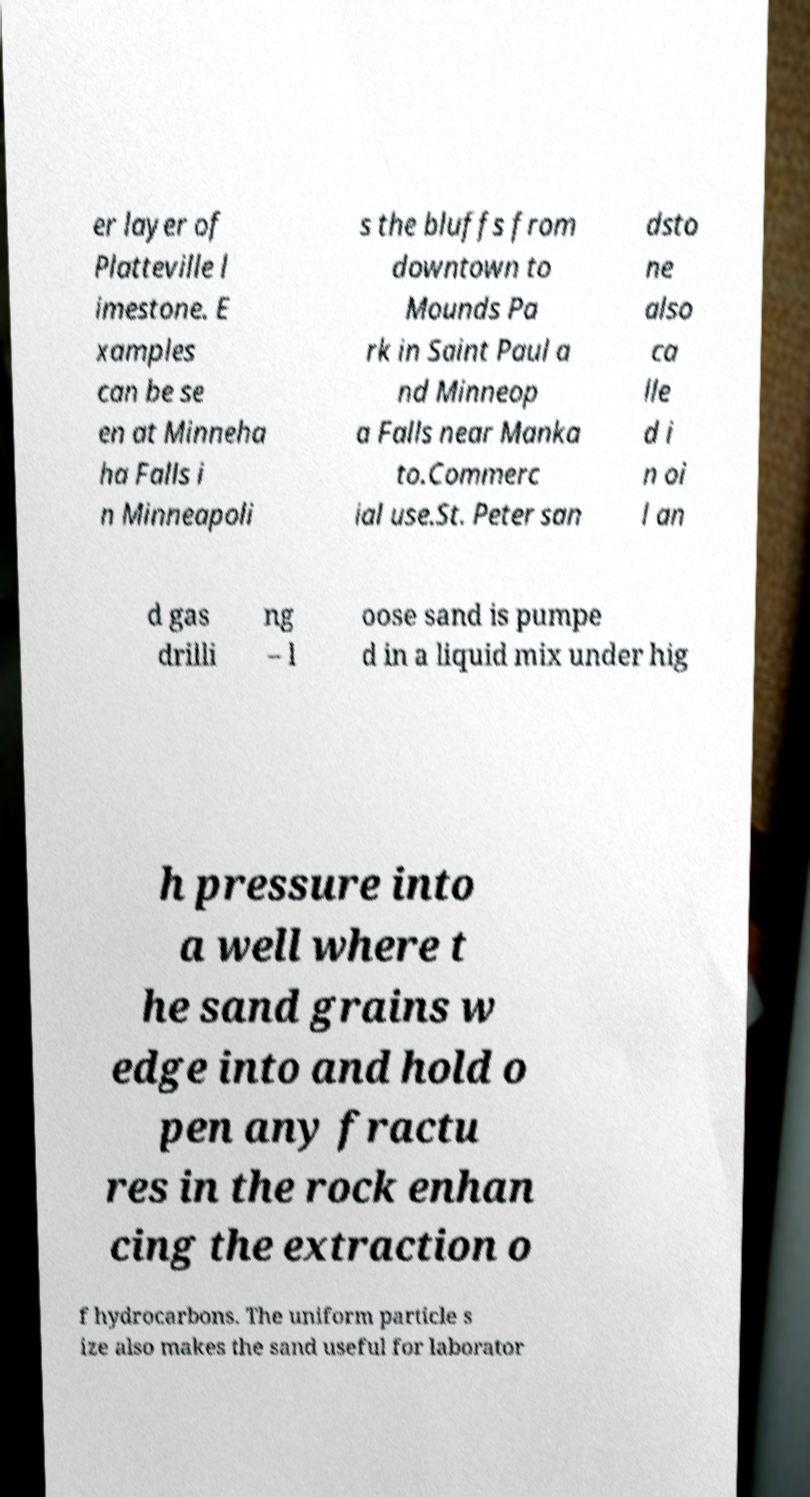I need the written content from this picture converted into text. Can you do that? er layer of Platteville l imestone. E xamples can be se en at Minneha ha Falls i n Minneapoli s the bluffs from downtown to Mounds Pa rk in Saint Paul a nd Minneop a Falls near Manka to.Commerc ial use.St. Peter san dsto ne also ca lle d i n oi l an d gas drilli ng – l oose sand is pumpe d in a liquid mix under hig h pressure into a well where t he sand grains w edge into and hold o pen any fractu res in the rock enhan cing the extraction o f hydrocarbons. The uniform particle s ize also makes the sand useful for laborator 